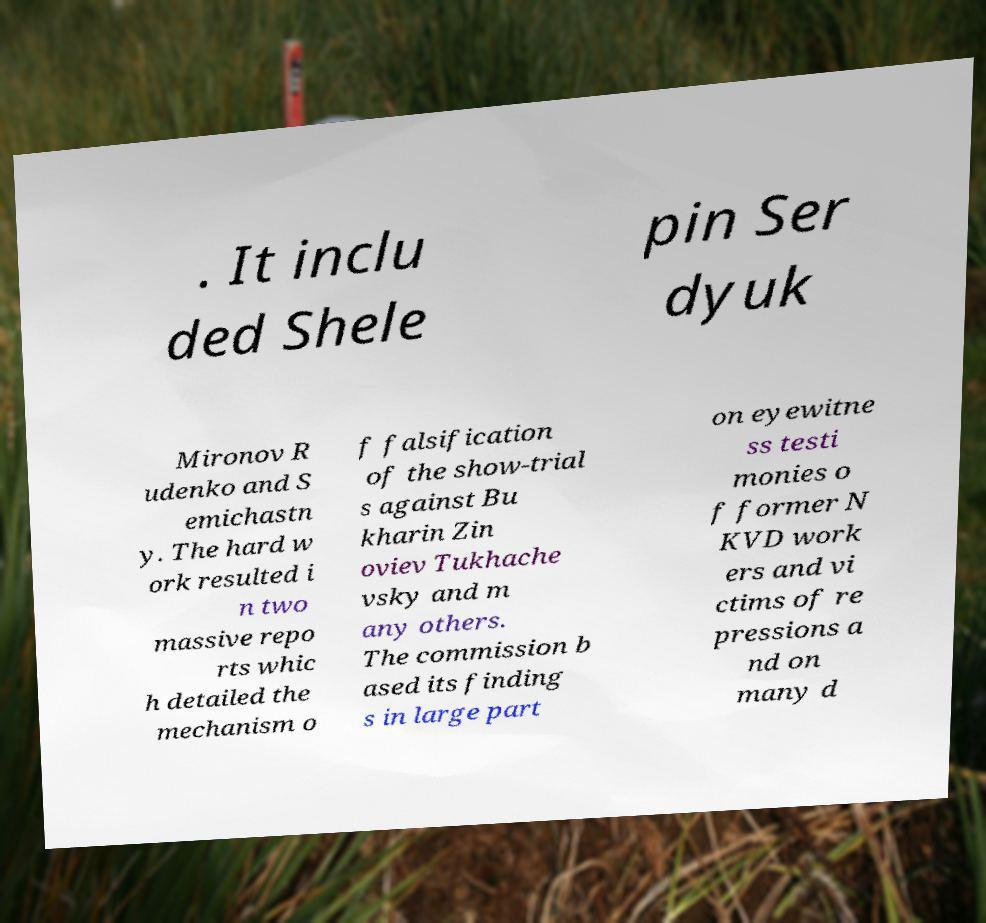For documentation purposes, I need the text within this image transcribed. Could you provide that? . It inclu ded Shele pin Ser dyuk Mironov R udenko and S emichastn y. The hard w ork resulted i n two massive repo rts whic h detailed the mechanism o f falsification of the show-trial s against Bu kharin Zin oviev Tukhache vsky and m any others. The commission b ased its finding s in large part on eyewitne ss testi monies o f former N KVD work ers and vi ctims of re pressions a nd on many d 